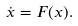<formula> <loc_0><loc_0><loc_500><loc_500>\dot { x } = F ( x ) .</formula> 